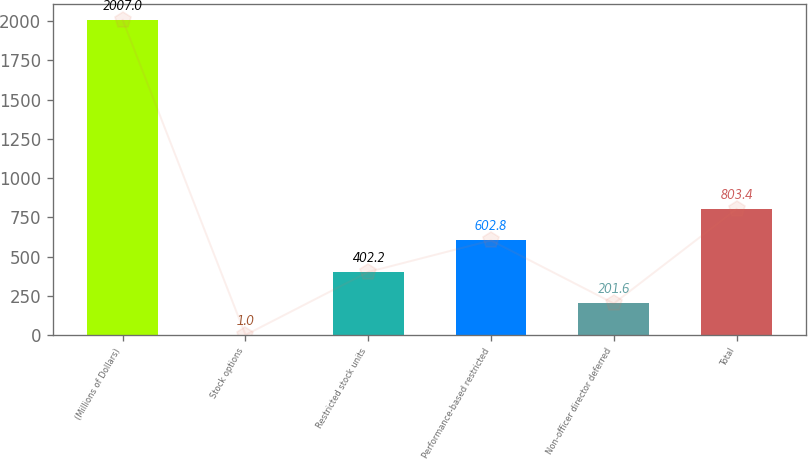<chart> <loc_0><loc_0><loc_500><loc_500><bar_chart><fcel>(Millions of Dollars)<fcel>Stock options<fcel>Restricted stock units<fcel>Performance-based restricted<fcel>Non-officer director deferred<fcel>Total<nl><fcel>2007<fcel>1<fcel>402.2<fcel>602.8<fcel>201.6<fcel>803.4<nl></chart> 